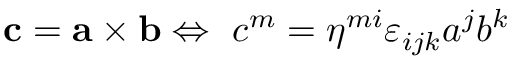Convert formula to latex. <formula><loc_0><loc_0><loc_500><loc_500>c = a \times b \Leftrightarrow \ c ^ { m } = \eta ^ { m i } \varepsilon _ { i j k } a ^ { j } b ^ { k }</formula> 